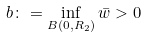<formula> <loc_0><loc_0><loc_500><loc_500>b \colon = \inf _ { B ( 0 , R _ { 2 } ) } \bar { w } > 0</formula> 